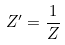Convert formula to latex. <formula><loc_0><loc_0><loc_500><loc_500>Z ^ { \prime } = \frac { 1 } { Z }</formula> 